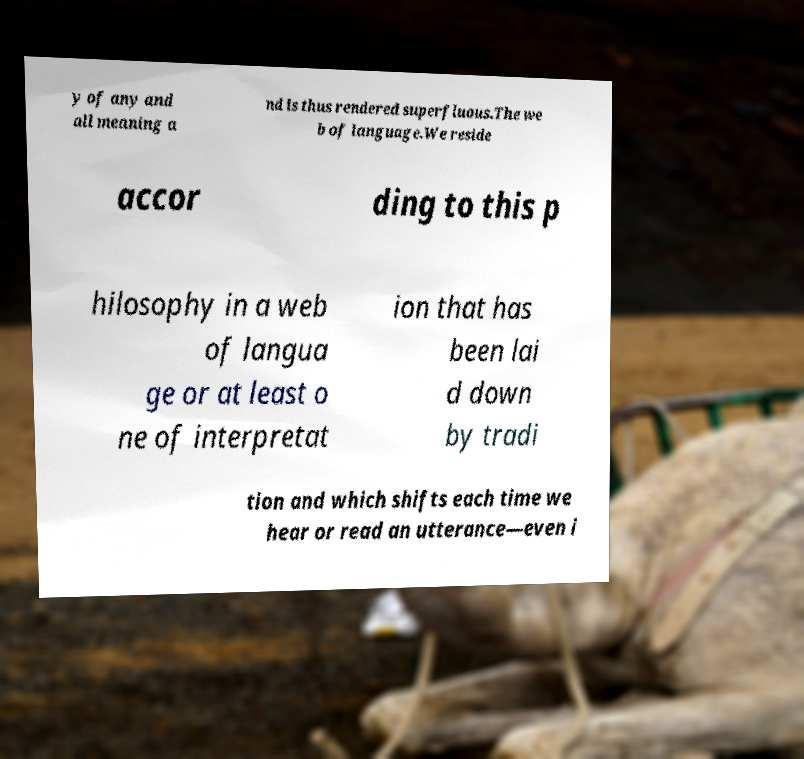What messages or text are displayed in this image? I need them in a readable, typed format. y of any and all meaning a nd is thus rendered superfluous.The we b of language.We reside accor ding to this p hilosophy in a web of langua ge or at least o ne of interpretat ion that has been lai d down by tradi tion and which shifts each time we hear or read an utterance—even i 